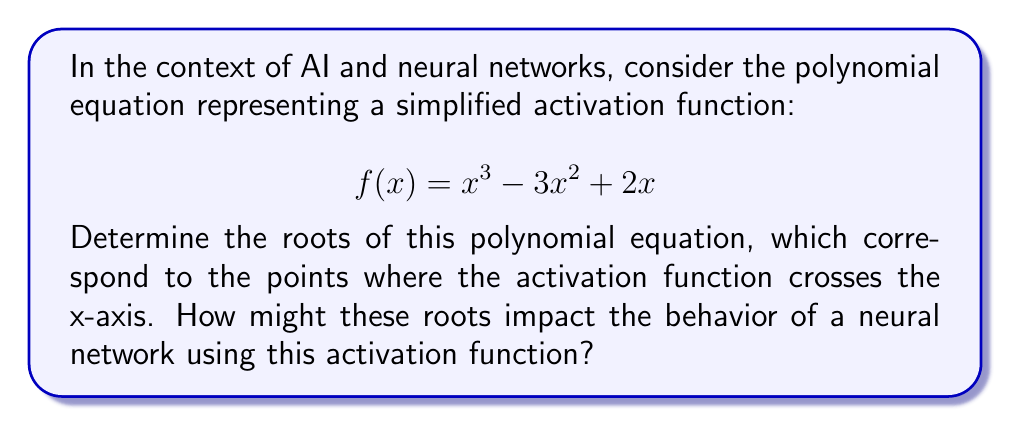Give your solution to this math problem. To find the roots of the polynomial equation $f(x) = x^3 - 3x^2 + 2x$, we need to solve for $f(x) = 0$:

1) First, factor out the common factor $x$:
   $$x^3 - 3x^2 + 2x = x(x^2 - 3x + 2) = 0$$

2) Using the zero product property, we can split this into two equations:
   $$x = 0 \quad \text{or} \quad x^2 - 3x + 2 = 0$$

3) We already have one root: $x = 0$

4) For the quadratic equation $x^2 - 3x + 2 = 0$, we can use the quadratic formula:
   $$x = \frac{-b \pm \sqrt{b^2 - 4ac}}{2a}$$
   where $a = 1$, $b = -3$, and $c = 2$

5) Substituting these values:
   $$x = \frac{3 \pm \sqrt{9 - 8}}{2} = \frac{3 \pm 1}{2}$$

6) This gives us two more roots:
   $$x = \frac{3 + 1}{2} = 2 \quad \text{and} \quad x = \frac{3 - 1}{2} = 1$$

The roots (0, 1, and 2) represent the points where the activation function crosses the x-axis. In a neural network:

- The root at x = 0 allows the function to pass through the origin, which can be useful for maintaining symmetry in the network's behavior.
- The roots at x = 1 and x = 2 create a non-linear response in the positive x range, which can help the network model complex patterns.
- The presence of multiple roots increases the function's non-linearity, potentially allowing the network to learn more complex mappings between inputs and outputs.
Answer: $x = 0, 1, 2$ 